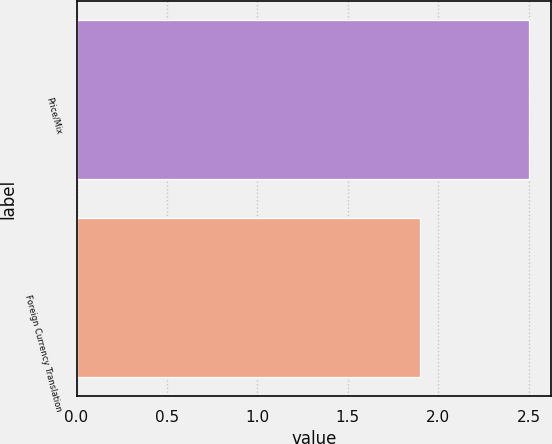Convert chart to OTSL. <chart><loc_0><loc_0><loc_500><loc_500><bar_chart><fcel>Price/Mix<fcel>Foreign Currency Translation<nl><fcel>2.5<fcel>1.9<nl></chart> 